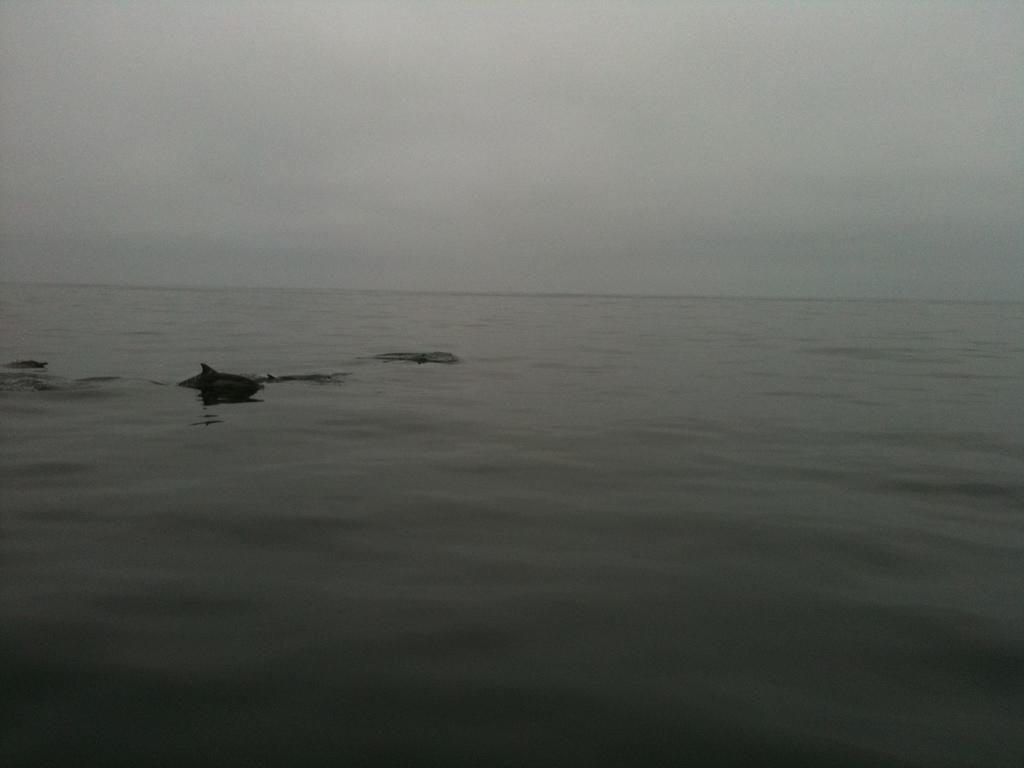Please provide a concise description of this image. There is a surface of water at the bottom of this image. It seems like there are some animals on the surface of water is on the left side of this image. There is a sky at the top of this image. 